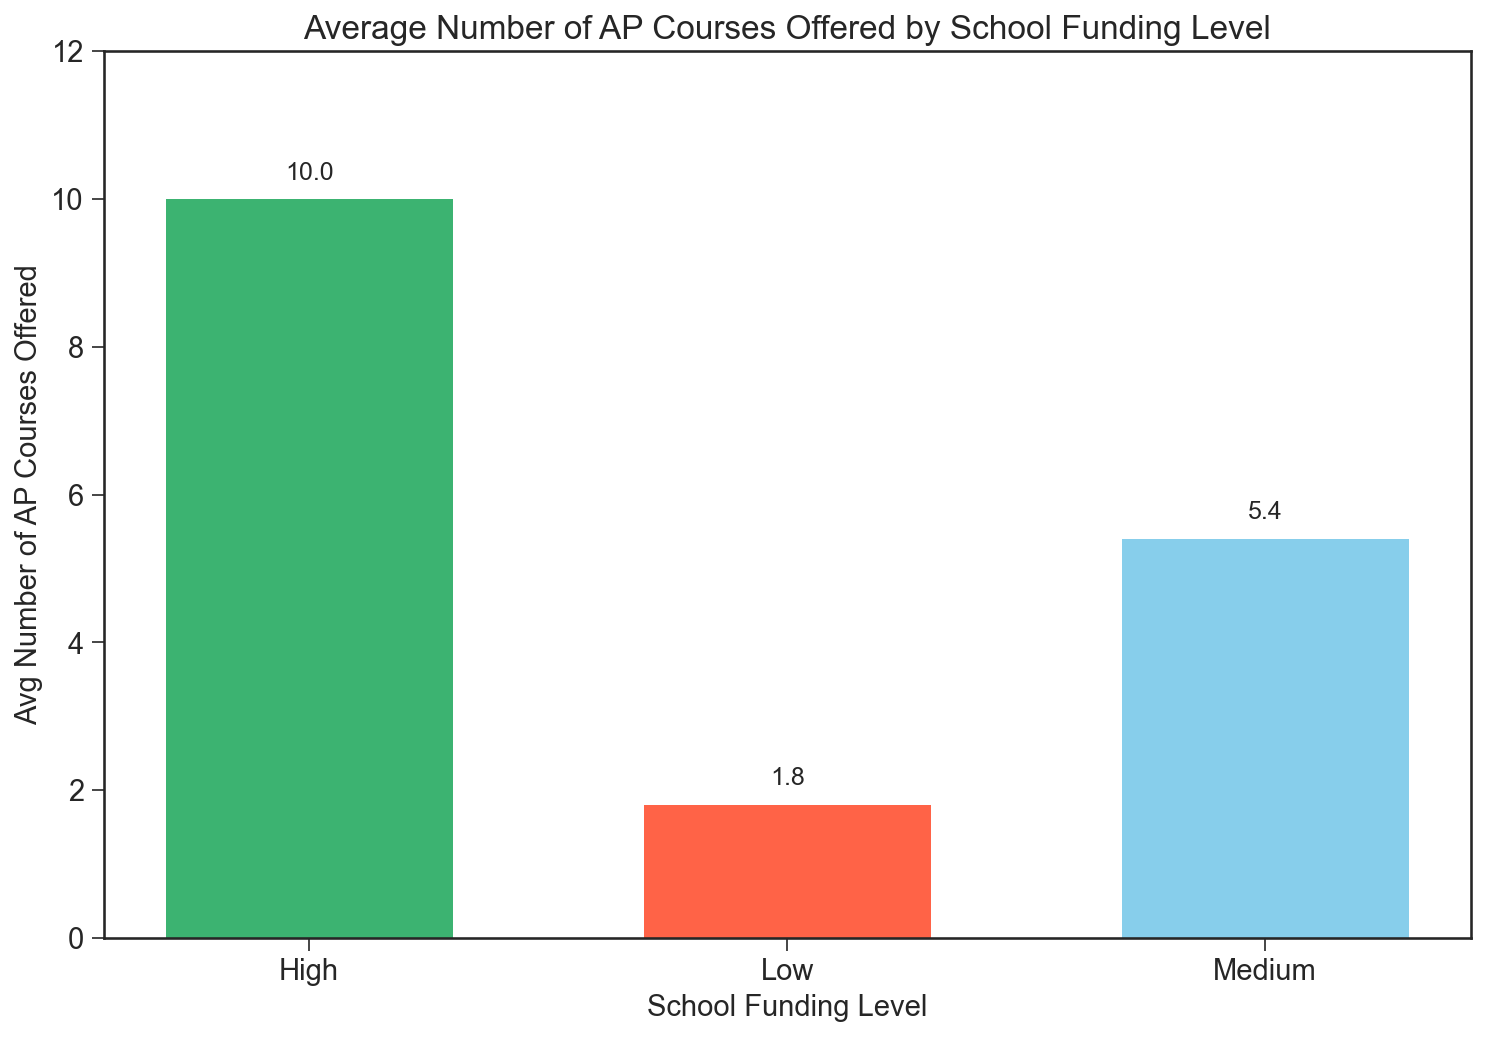What is the average number of AP courses offered by schools with low funding? The average number of AP courses offered by schools with low funding can be found directly from the figure. Identify the height of the bar corresponding to "Low" funding level.
Answer: 1.8 How does the average number of AP courses offered by high funding schools compare to those offered by medium funding schools? To find out how high funding schools compare to medium funding schools, observe the heights of the respective bars. The bar for high funding schools is taller than that for medium funding schools.
Answer: High funding schools offer more AP courses on average than medium funding schools What is the difference in the average number of AP courses offered between high and low funding schools? Subtract the average number of AP courses offered by low funding schools from that offered by high funding schools using the heights of the respective bars.
Answer: 9.67 - 1.8 = 7.87 How many more AP courses, on average, do high funding schools offer compared to medium funding schools? Subtract the average number of AP courses offered by medium funding schools from that offered by high funding schools using the heights of the respective bars.
Answer: 9.67 - 5.4 = 4.27 Which funding level has the least average number of AP courses offered? Identify the shortest bar in the plot. The bar corresponding to the "Low" funding level is the shortest.
Answer: Low Among the funding levels, which one provides the highest average number of AP courses? Identify the tallest bar in the plot. The bar corresponding to the "High" funding level is the tallest.
Answer: High If you add the average number of AP courses offered by low and medium funding schools, what do you get? By summing the heights of the bars for low and medium funding schools. You get \(1.8 + 5.4\).
Answer: 7.2 How many times more AP courses do high funding schools offer compared to low funding schools, on average? Divide the average number of AP courses for high funding schools by that for low funding schools. That is \(\frac{9.67}{1.8}\).
Answer: 5.37 times 